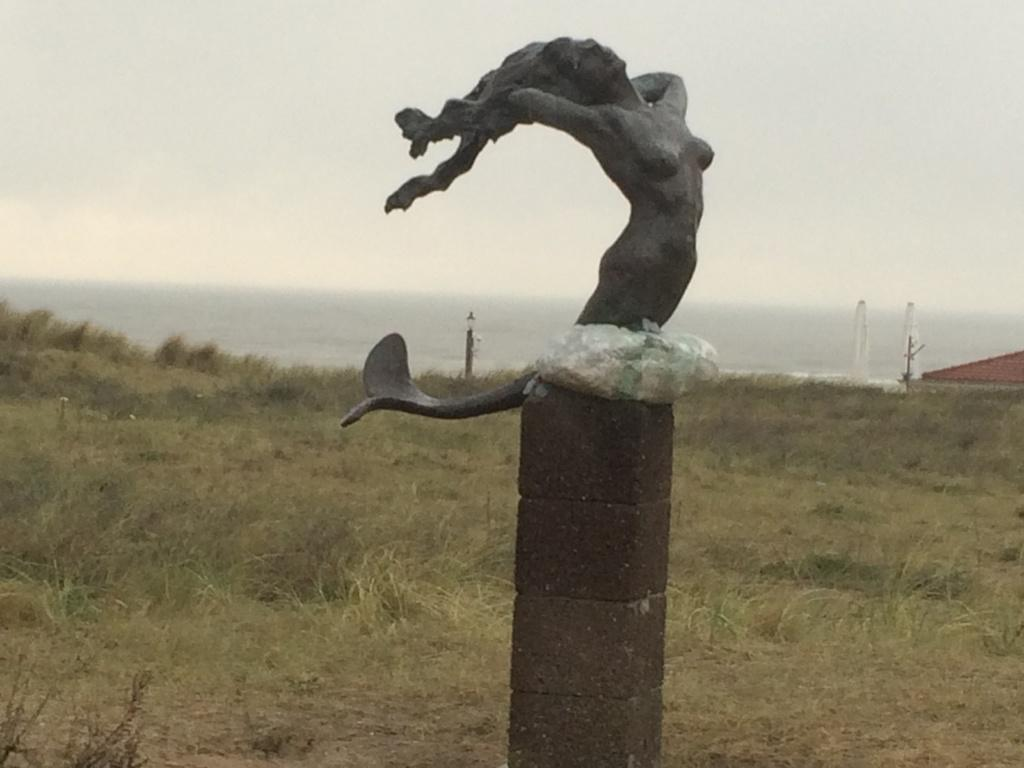What is located on the ground in the image? There is a statue on the ground in the image. What type of vegetation is present in the image? There is grass in the image. What structures can be seen in the image? There are poles in the image. What is visible in the background of the image? The sky is visible in the background of the image. What type of meal is being prepared on the quilt in the image? There is no meal or quilt present in the image; it features a statue, grass, poles, and the sky. 